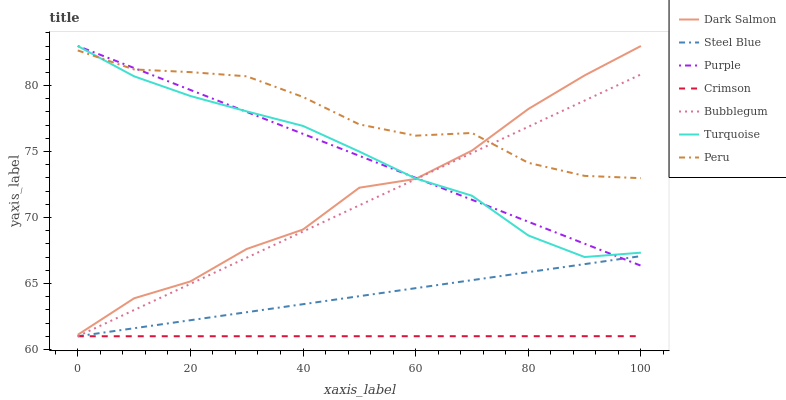Does Crimson have the minimum area under the curve?
Answer yes or no. Yes. Does Peru have the maximum area under the curve?
Answer yes or no. Yes. Does Purple have the minimum area under the curve?
Answer yes or no. No. Does Purple have the maximum area under the curve?
Answer yes or no. No. Is Steel Blue the smoothest?
Answer yes or no. Yes. Is Dark Salmon the roughest?
Answer yes or no. Yes. Is Purple the smoothest?
Answer yes or no. No. Is Purple the roughest?
Answer yes or no. No. Does Bubblegum have the lowest value?
Answer yes or no. Yes. Does Purple have the lowest value?
Answer yes or no. No. Does Dark Salmon have the highest value?
Answer yes or no. Yes. Does Bubblegum have the highest value?
Answer yes or no. No. Is Crimson less than Turquoise?
Answer yes or no. Yes. Is Turquoise greater than Steel Blue?
Answer yes or no. Yes. Does Bubblegum intersect Crimson?
Answer yes or no. Yes. Is Bubblegum less than Crimson?
Answer yes or no. No. Is Bubblegum greater than Crimson?
Answer yes or no. No. Does Crimson intersect Turquoise?
Answer yes or no. No. 